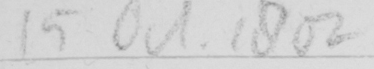Please transcribe the handwritten text in this image. 15 Oct 1802 